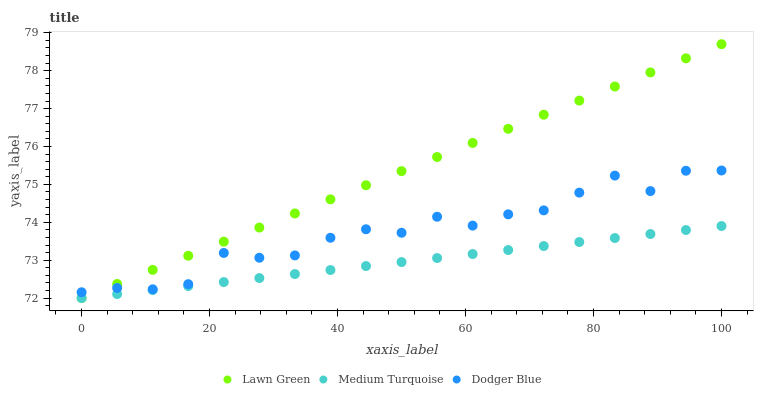Does Medium Turquoise have the minimum area under the curve?
Answer yes or no. Yes. Does Lawn Green have the maximum area under the curve?
Answer yes or no. Yes. Does Dodger Blue have the minimum area under the curve?
Answer yes or no. No. Does Dodger Blue have the maximum area under the curve?
Answer yes or no. No. Is Medium Turquoise the smoothest?
Answer yes or no. Yes. Is Dodger Blue the roughest?
Answer yes or no. Yes. Is Dodger Blue the smoothest?
Answer yes or no. No. Is Medium Turquoise the roughest?
Answer yes or no. No. Does Lawn Green have the lowest value?
Answer yes or no. Yes. Does Dodger Blue have the lowest value?
Answer yes or no. No. Does Lawn Green have the highest value?
Answer yes or no. Yes. Does Dodger Blue have the highest value?
Answer yes or no. No. Is Medium Turquoise less than Dodger Blue?
Answer yes or no. Yes. Is Dodger Blue greater than Medium Turquoise?
Answer yes or no. Yes. Does Lawn Green intersect Medium Turquoise?
Answer yes or no. Yes. Is Lawn Green less than Medium Turquoise?
Answer yes or no. No. Is Lawn Green greater than Medium Turquoise?
Answer yes or no. No. Does Medium Turquoise intersect Dodger Blue?
Answer yes or no. No. 